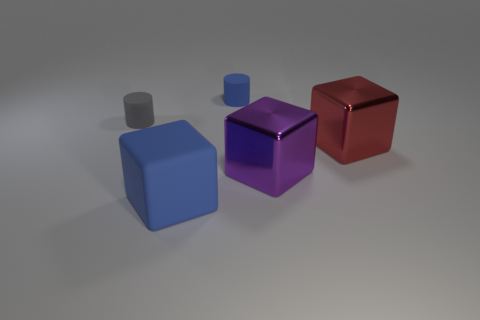There is another small rubber object that is the same shape as the gray object; what color is it?
Provide a succinct answer. Blue. Does the cylinder on the left side of the big matte cube have the same color as the small rubber thing on the right side of the tiny gray rubber object?
Your answer should be very brief. No. Is the number of small matte objects that are in front of the purple object greater than the number of big cyan rubber balls?
Your answer should be very brief. No. How many other things are there of the same size as the gray object?
Keep it short and to the point. 1. How many things are both on the right side of the blue matte block and left of the tiny blue matte object?
Give a very brief answer. 0. Does the tiny cylinder that is behind the gray rubber cylinder have the same material as the large red block?
Offer a terse response. No. The tiny thing to the left of the cylinder on the right side of the tiny cylinder that is to the left of the large blue rubber block is what shape?
Make the answer very short. Cylinder. Is the number of tiny objects that are to the right of the small blue rubber cylinder the same as the number of gray rubber things in front of the big blue rubber block?
Your answer should be compact. Yes. The thing that is the same size as the blue cylinder is what color?
Ensure brevity in your answer.  Gray. What number of large objects are matte things or red things?
Offer a terse response. 2. 